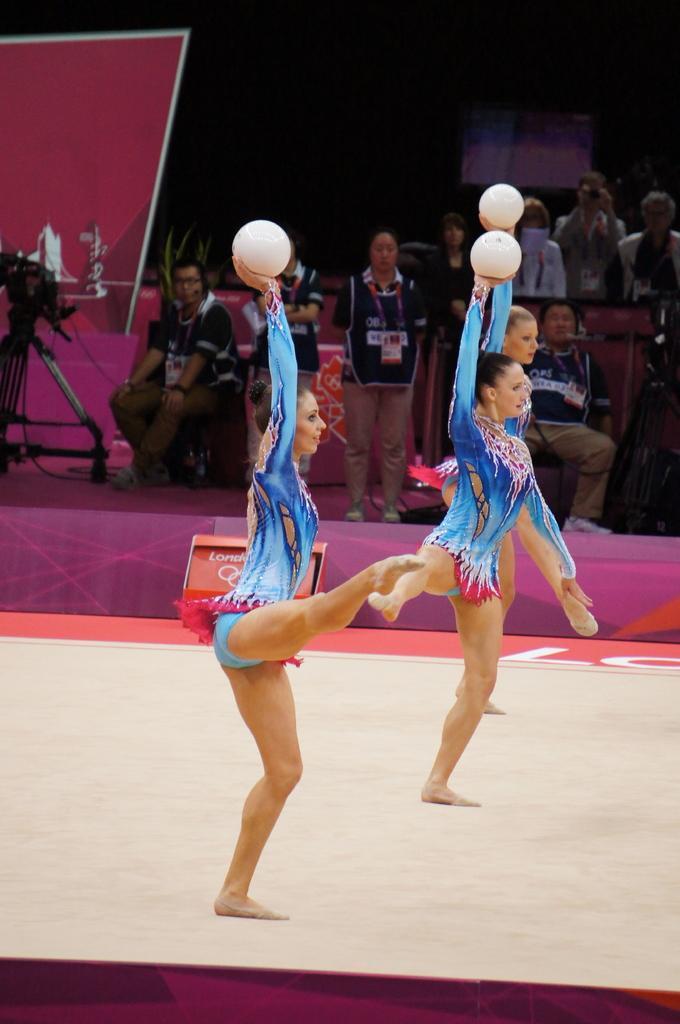How would you summarize this image in a sentence or two? In this image there are three ladies performing gymnastics on a floor, in the background there are people sitting and few are standing. 